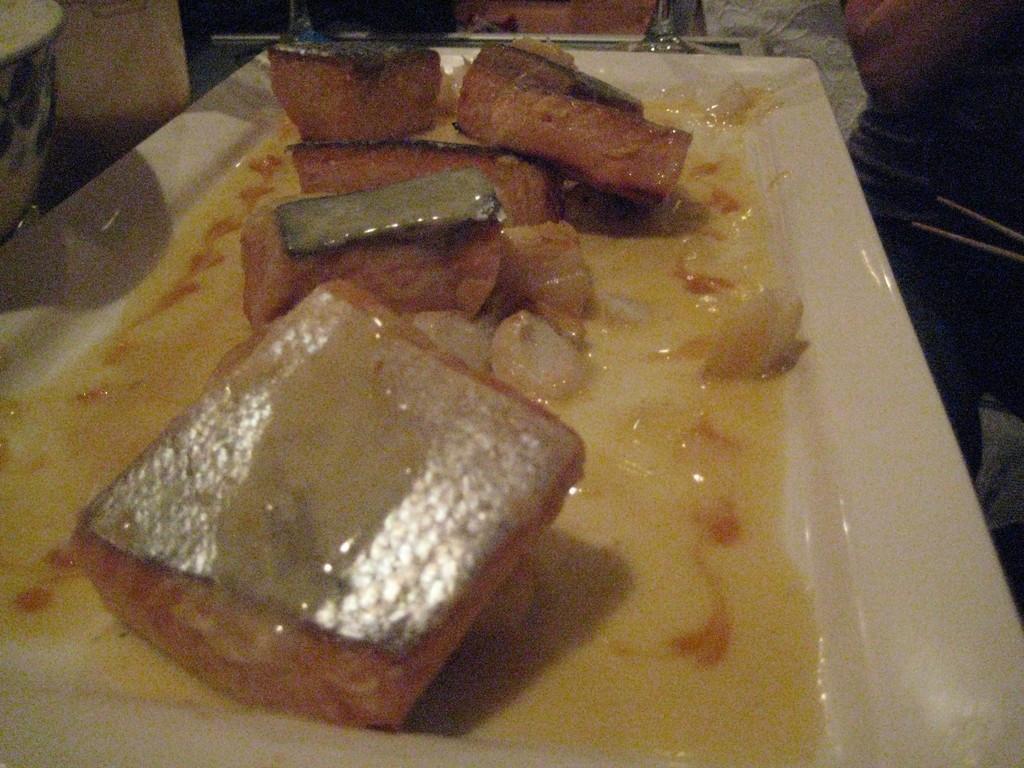How would you summarize this image in a sentence or two? Here we can see food items and soup in a plate. In the background there are some objects. 